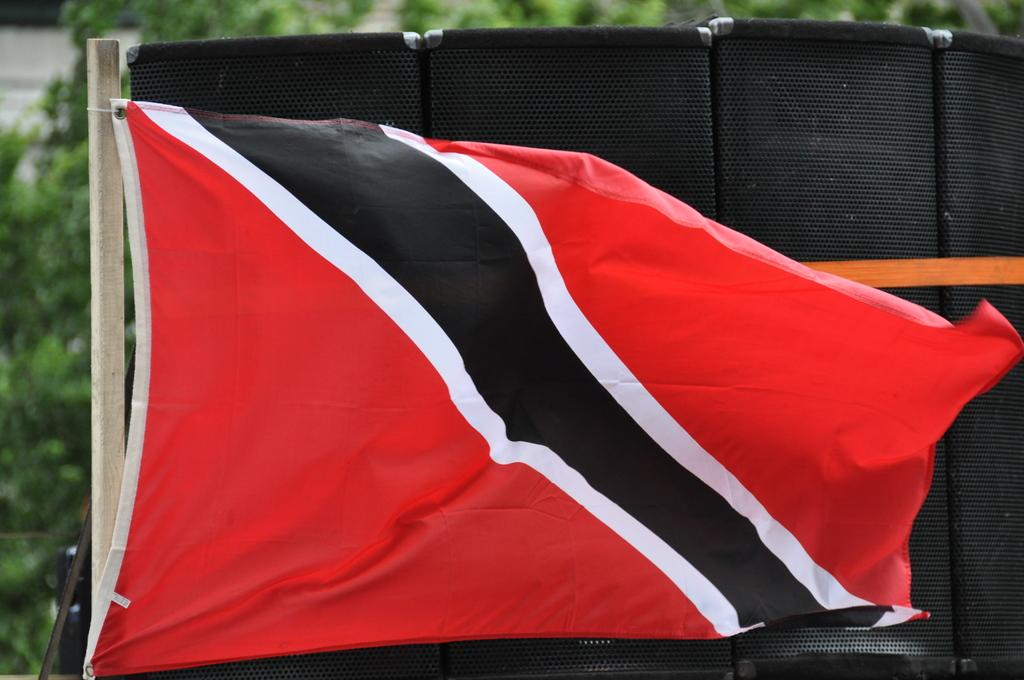What is attached to the pole in the image? There is a flag on a pole in the image. What can be used for amplifying sound in the image? There are speakers visible in the image. What type of vegetation is present in the image? Green leaves are present in the image. Can you see a laborer working on the sidewalk in the image? There is no sidewalk or laborer present in the image. What type of pen is being used to write on the green leaves in the image? There is no pen or writing on the green leaves in the image. 